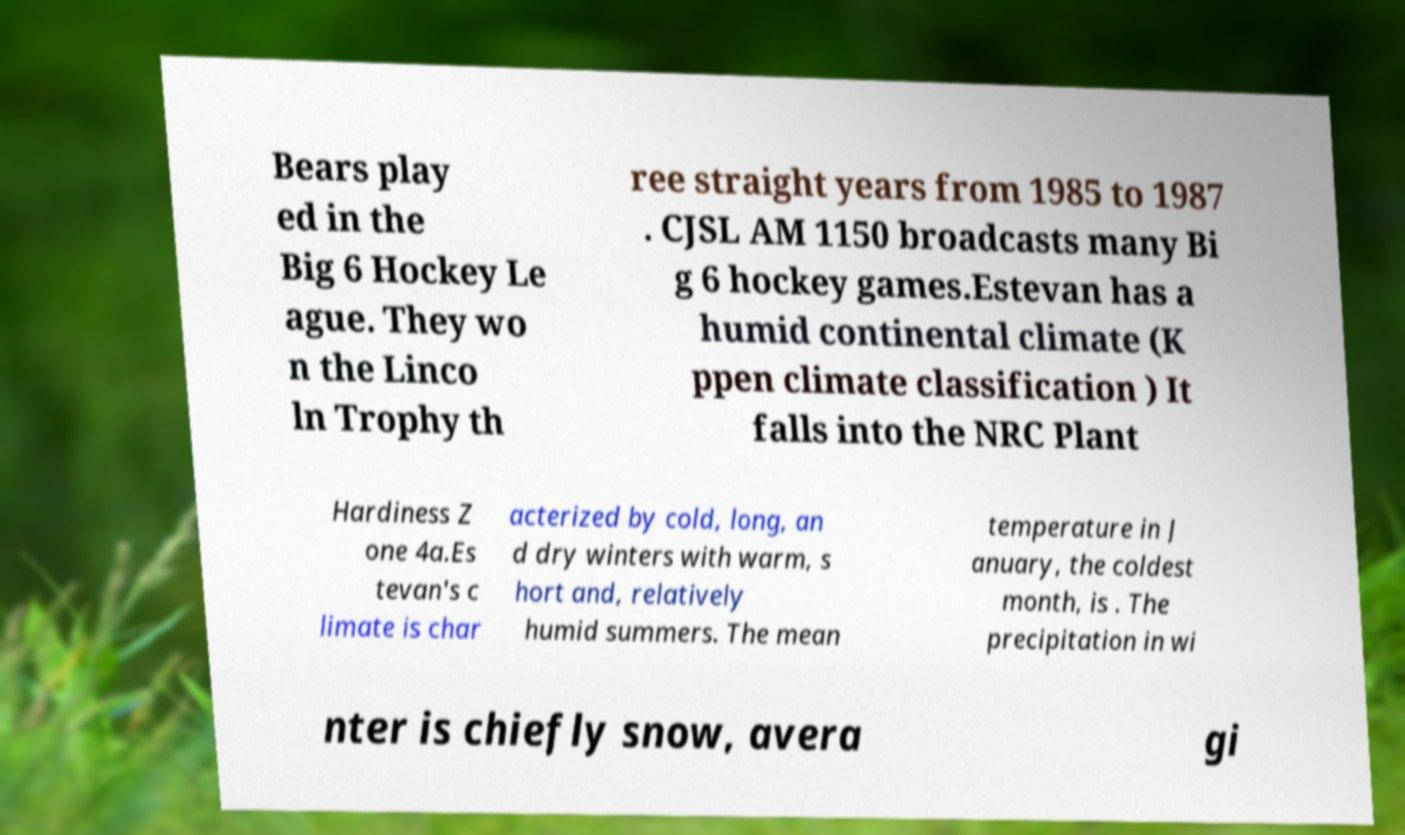I need the written content from this picture converted into text. Can you do that? Bears play ed in the Big 6 Hockey Le ague. They wo n the Linco ln Trophy th ree straight years from 1985 to 1987 . CJSL AM 1150 broadcasts many Bi g 6 hockey games.Estevan has a humid continental climate (K ppen climate classification ) It falls into the NRC Plant Hardiness Z one 4a.Es tevan's c limate is char acterized by cold, long, an d dry winters with warm, s hort and, relatively humid summers. The mean temperature in J anuary, the coldest month, is . The precipitation in wi nter is chiefly snow, avera gi 